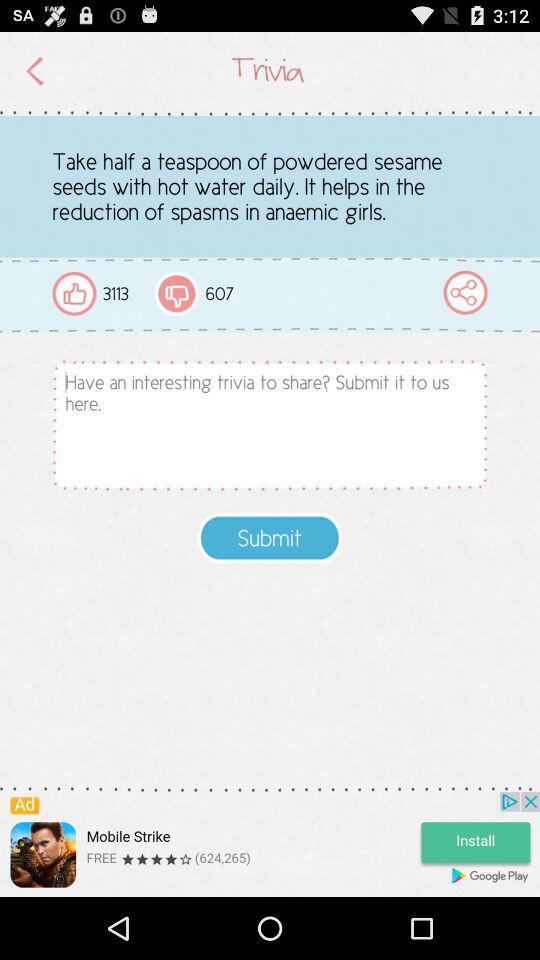How many people have disliked trivia? There are 607 people who dislike trivia. 